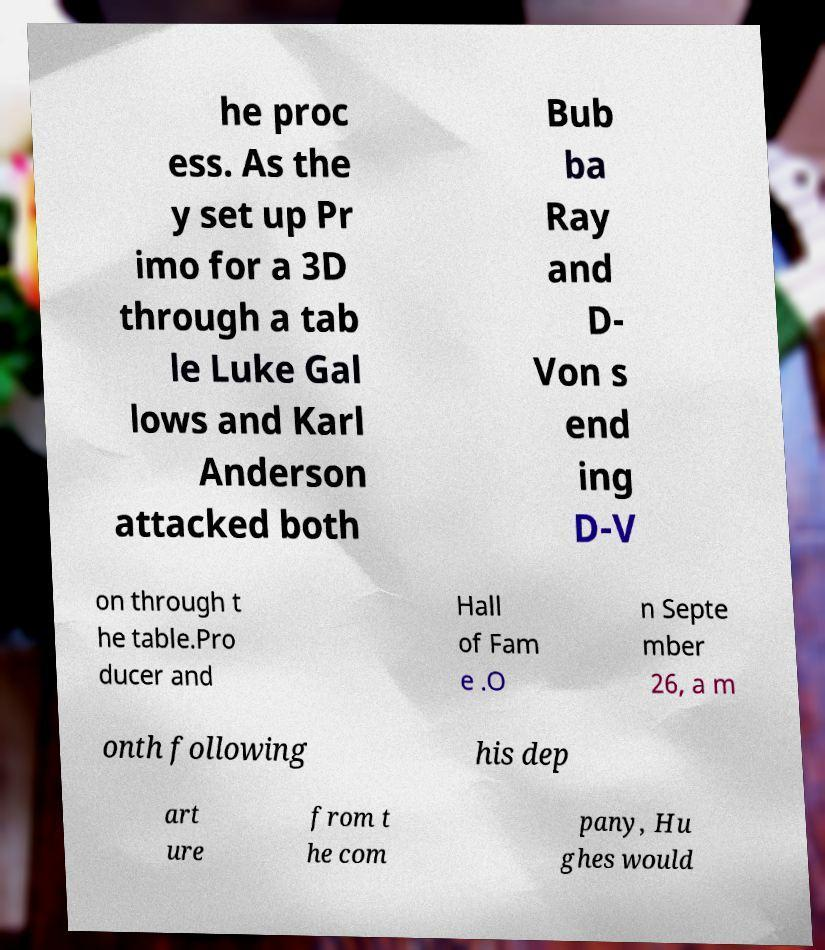Please read and relay the text visible in this image. What does it say? he proc ess. As the y set up Pr imo for a 3D through a tab le Luke Gal lows and Karl Anderson attacked both Bub ba Ray and D- Von s end ing D-V on through t he table.Pro ducer and Hall of Fam e .O n Septe mber 26, a m onth following his dep art ure from t he com pany, Hu ghes would 